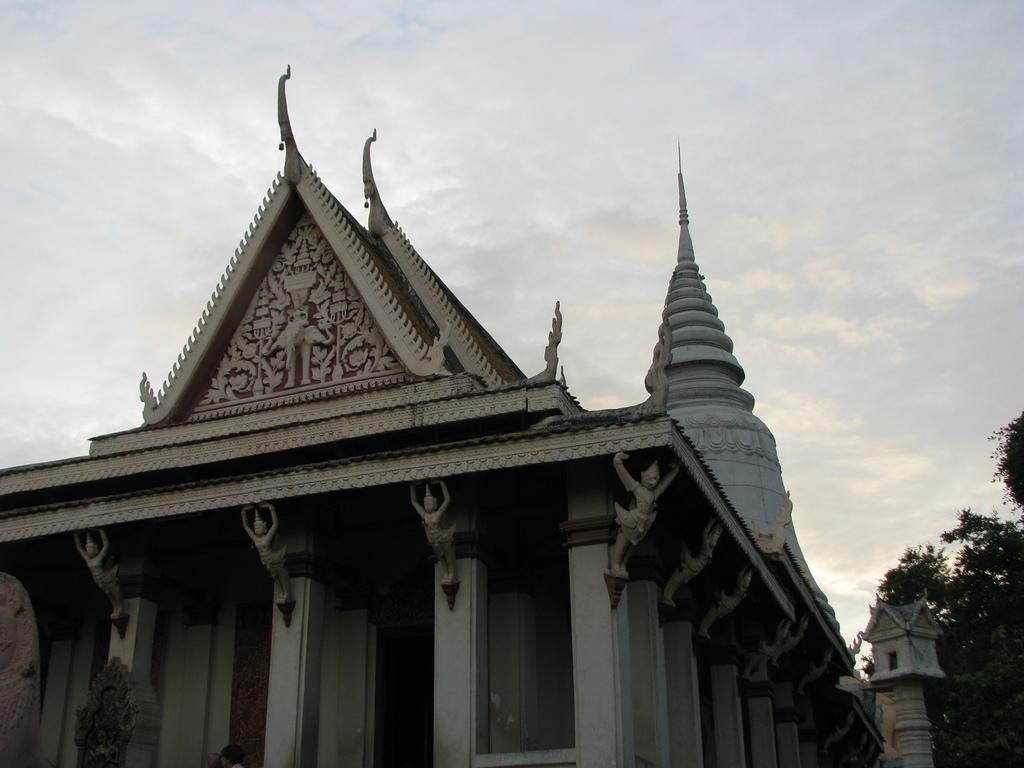What type of structure is featured in the image? There is a building with sculptures in the image. What can be seen on the right side of the image? There are trees on the right side of the image. What is visible in the background of the image? The sky is visible in the background of the image. What is the chance of winning a prize if you open the door in the image? There is no door present in the image, so it is not possible to answer that question. 